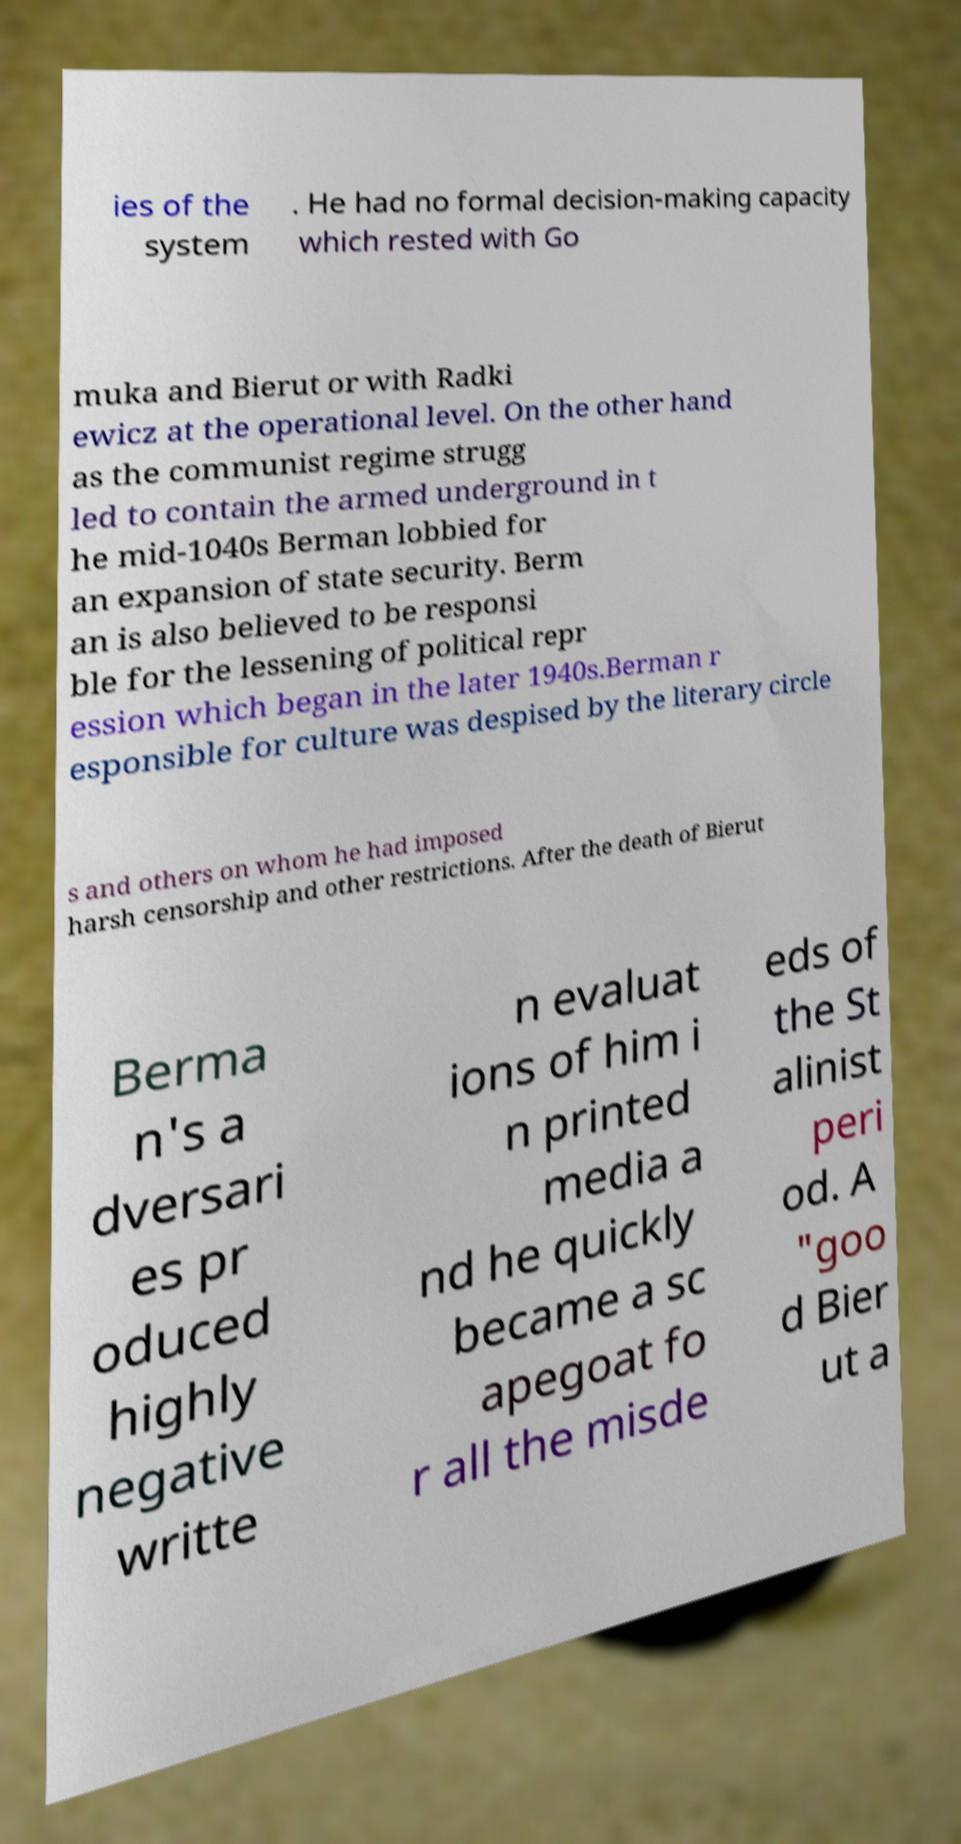Can you read and provide the text displayed in the image?This photo seems to have some interesting text. Can you extract and type it out for me? ies of the system . He had no formal decision-making capacity which rested with Go muka and Bierut or with Radki ewicz at the operational level. On the other hand as the communist regime strugg led to contain the armed underground in t he mid-1040s Berman lobbied for an expansion of state security. Berm an is also believed to be responsi ble for the lessening of political repr ession which began in the later 1940s.Berman r esponsible for culture was despised by the literary circle s and others on whom he had imposed harsh censorship and other restrictions. After the death of Bierut Berma n's a dversari es pr oduced highly negative writte n evaluat ions of him i n printed media a nd he quickly became a sc apegoat fo r all the misde eds of the St alinist peri od. A "goo d Bier ut a 